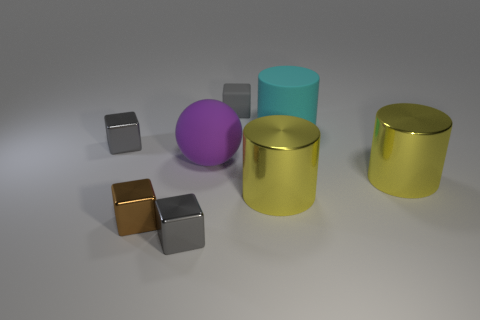There is a thing that is on the right side of the big matte object behind the gray metallic block that is behind the small brown metal object; what is its size?
Your answer should be compact. Large. What number of cyan cylinders are the same material as the purple thing?
Provide a succinct answer. 1. Are there fewer purple balls than large yellow metal objects?
Provide a succinct answer. Yes. What size is the matte thing that is the same shape as the small brown metallic object?
Provide a succinct answer. Small. Is the large object on the left side of the gray matte object made of the same material as the big cyan cylinder?
Your response must be concise. Yes. Is the shape of the big purple thing the same as the brown object?
Give a very brief answer. No. How many objects are big matte things on the left side of the gray rubber thing or big balls?
Your answer should be very brief. 1. What size is the sphere that is made of the same material as the large cyan cylinder?
Ensure brevity in your answer.  Large. How many things are the same color as the rubber block?
Make the answer very short. 2. What number of large things are shiny things or yellow objects?
Your answer should be very brief. 2. 